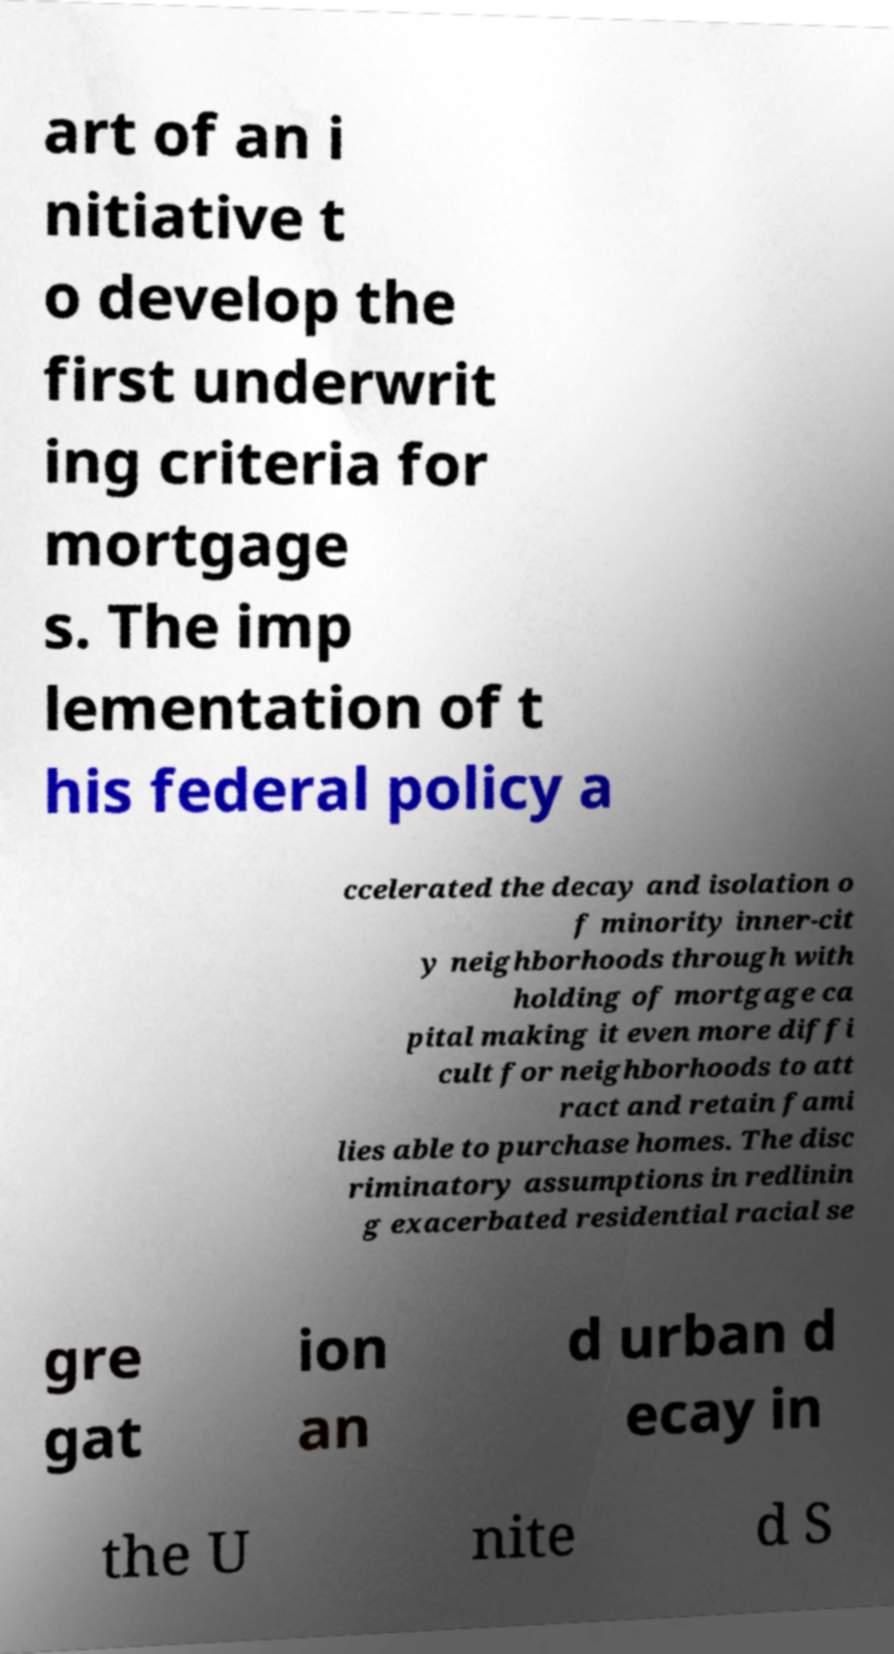Please identify and transcribe the text found in this image. art of an i nitiative t o develop the first underwrit ing criteria for mortgage s. The imp lementation of t his federal policy a ccelerated the decay and isolation o f minority inner-cit y neighborhoods through with holding of mortgage ca pital making it even more diffi cult for neighborhoods to att ract and retain fami lies able to purchase homes. The disc riminatory assumptions in redlinin g exacerbated residential racial se gre gat ion an d urban d ecay in the U nite d S 